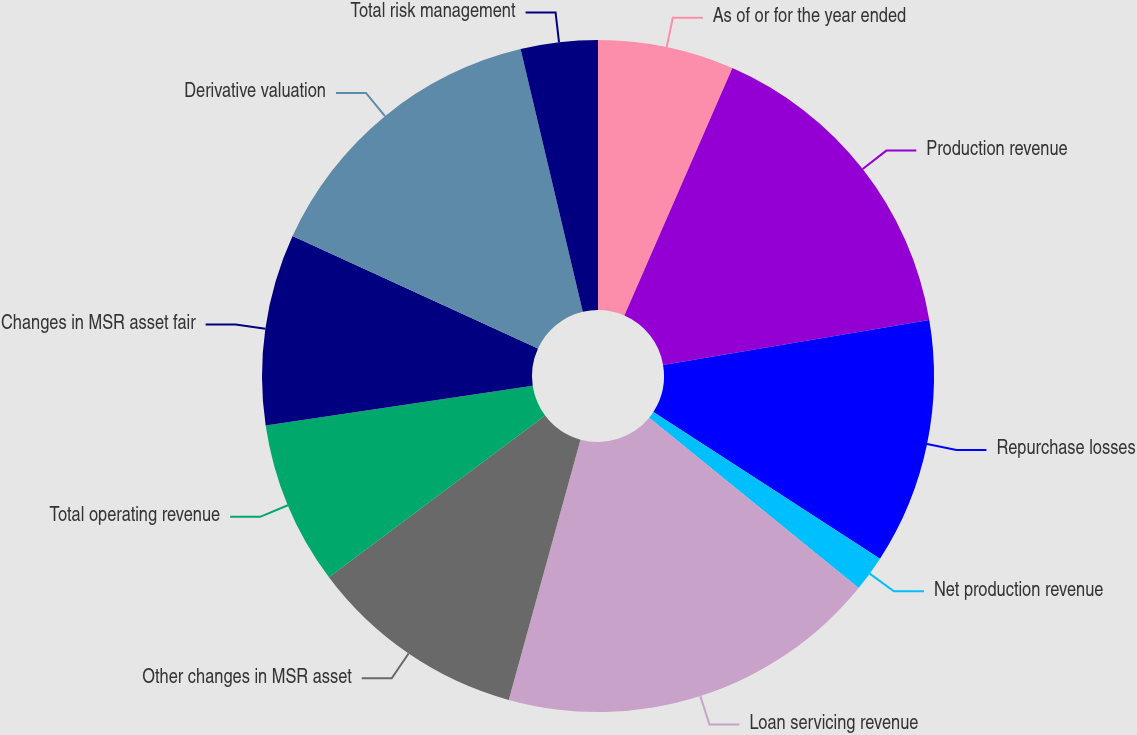<chart> <loc_0><loc_0><loc_500><loc_500><pie_chart><fcel>As of or for the year ended<fcel>Production revenue<fcel>Repurchase losses<fcel>Net production revenue<fcel>Loan servicing revenue<fcel>Other changes in MSR asset<fcel>Total operating revenue<fcel>Changes in MSR asset fair<fcel>Derivative valuation<fcel>Total risk management<nl><fcel>6.55%<fcel>15.78%<fcel>11.82%<fcel>1.72%<fcel>18.41%<fcel>10.5%<fcel>7.87%<fcel>9.19%<fcel>14.46%<fcel>3.7%<nl></chart> 